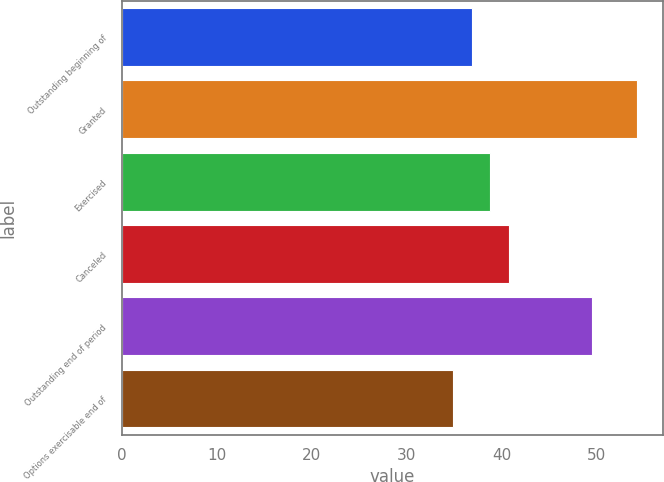Convert chart. <chart><loc_0><loc_0><loc_500><loc_500><bar_chart><fcel>Outstanding beginning of<fcel>Granted<fcel>Exercised<fcel>Canceled<fcel>Outstanding end of period<fcel>Options exercisable end of<nl><fcel>36.86<fcel>54.3<fcel>38.8<fcel>40.74<fcel>49.53<fcel>34.92<nl></chart> 